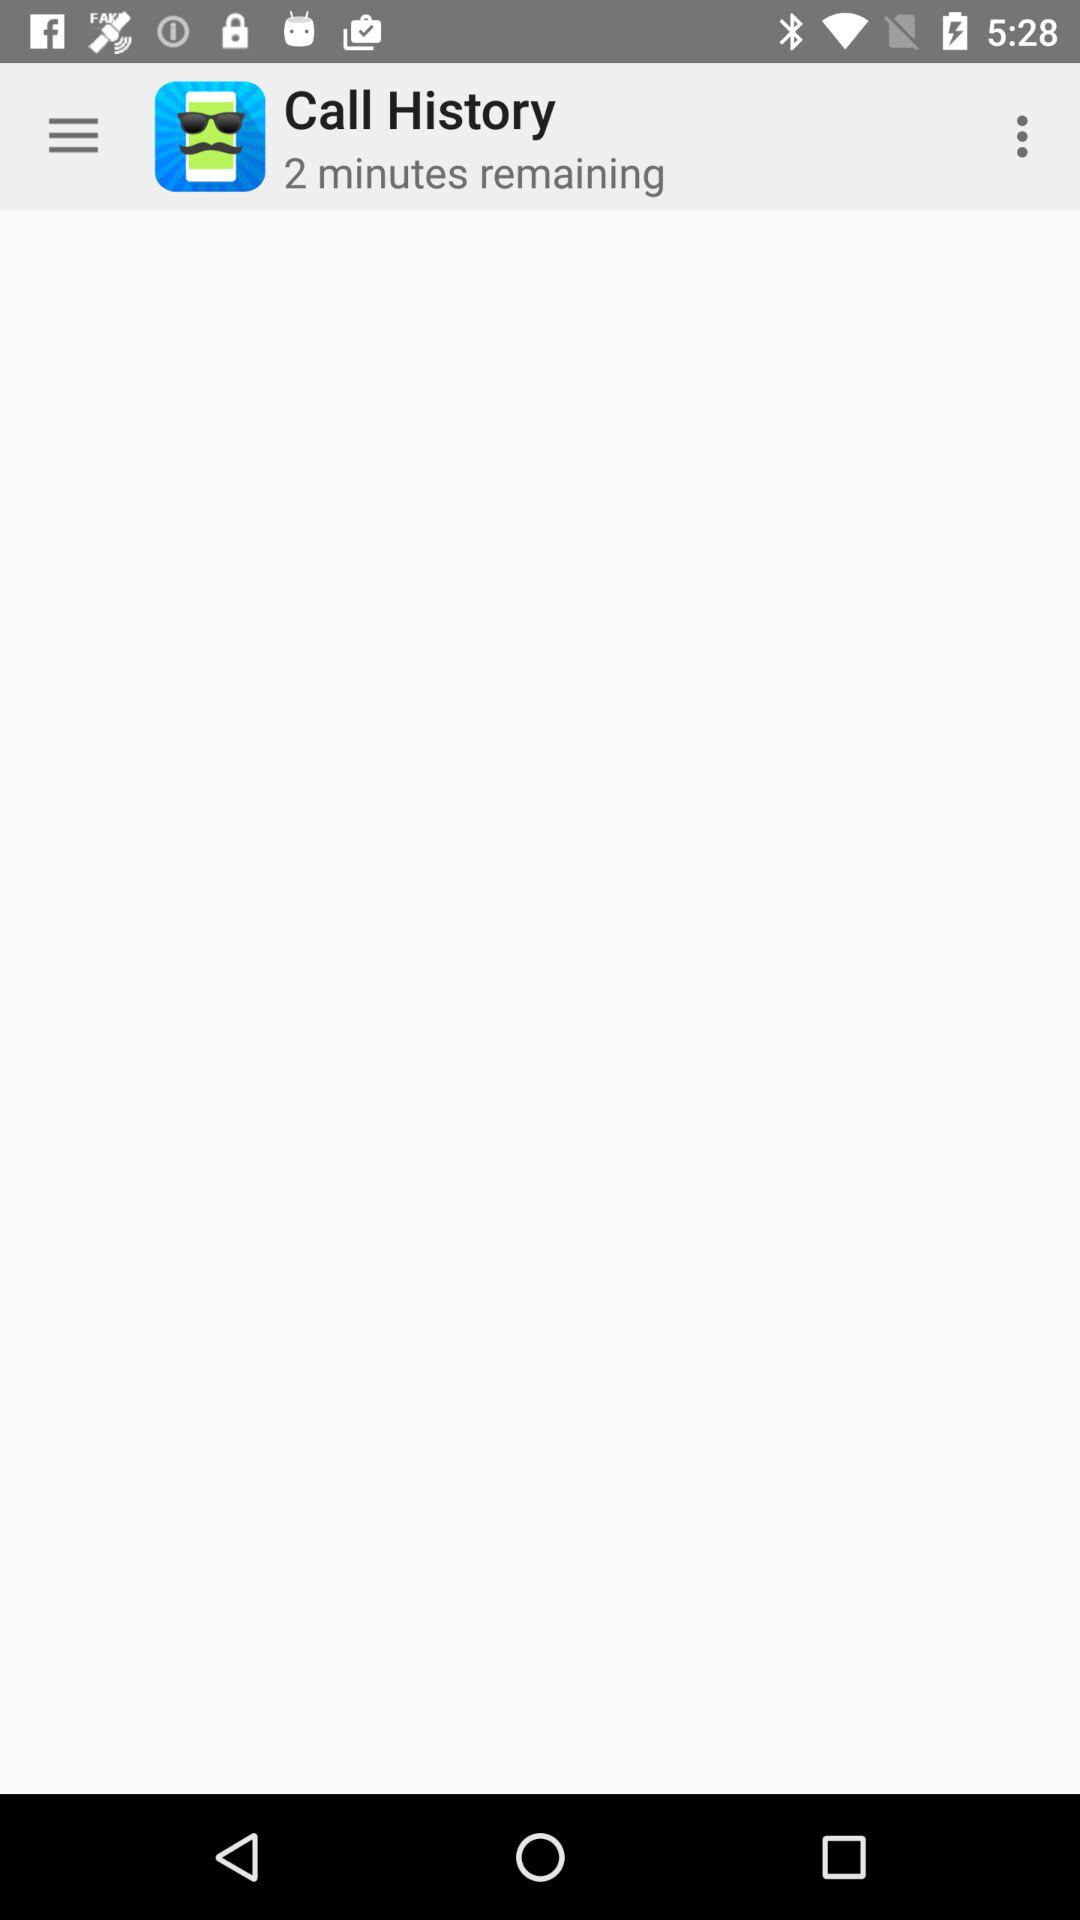What is the name of the application? The name of the application is "Caller ID Faker". 